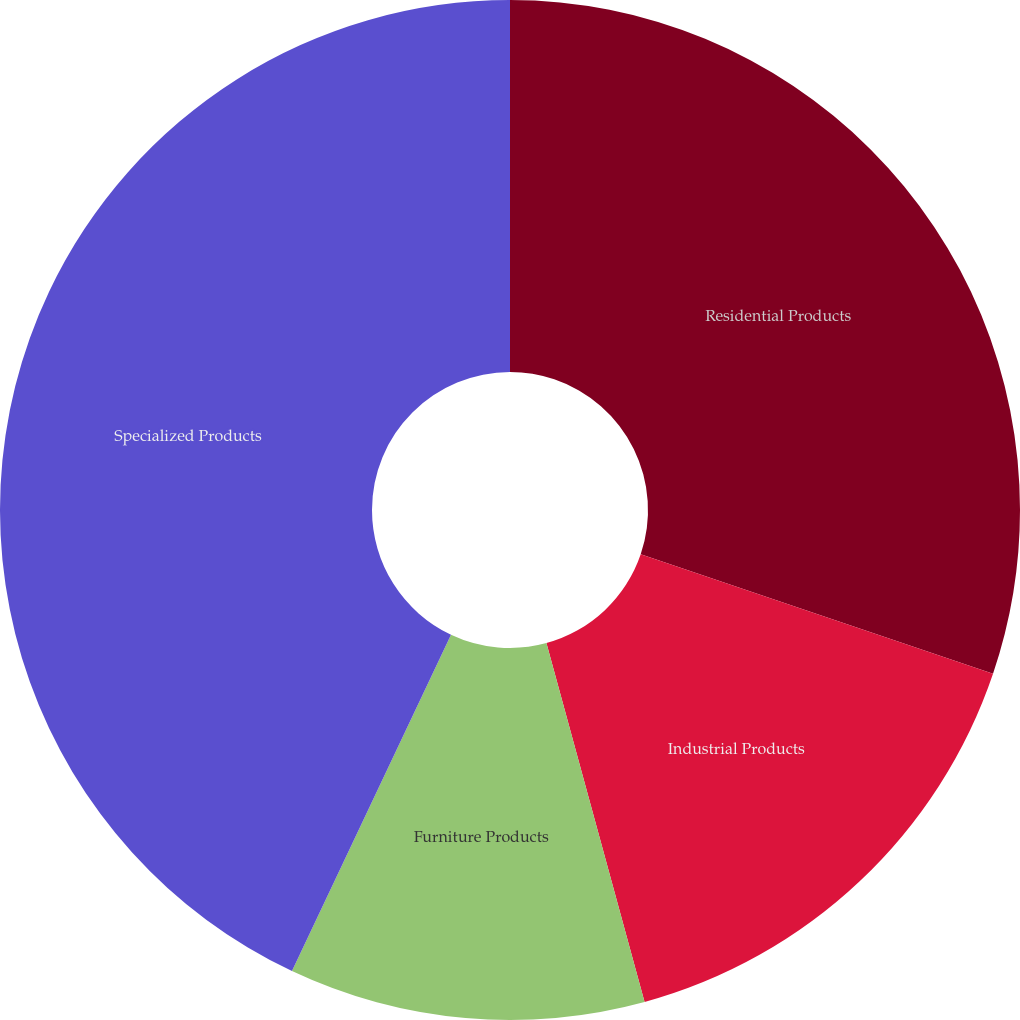<chart> <loc_0><loc_0><loc_500><loc_500><pie_chart><fcel>Residential Products<fcel>Industrial Products<fcel>Furniture Products<fcel>Specialized Products<nl><fcel>30.2%<fcel>15.55%<fcel>11.28%<fcel>42.97%<nl></chart> 